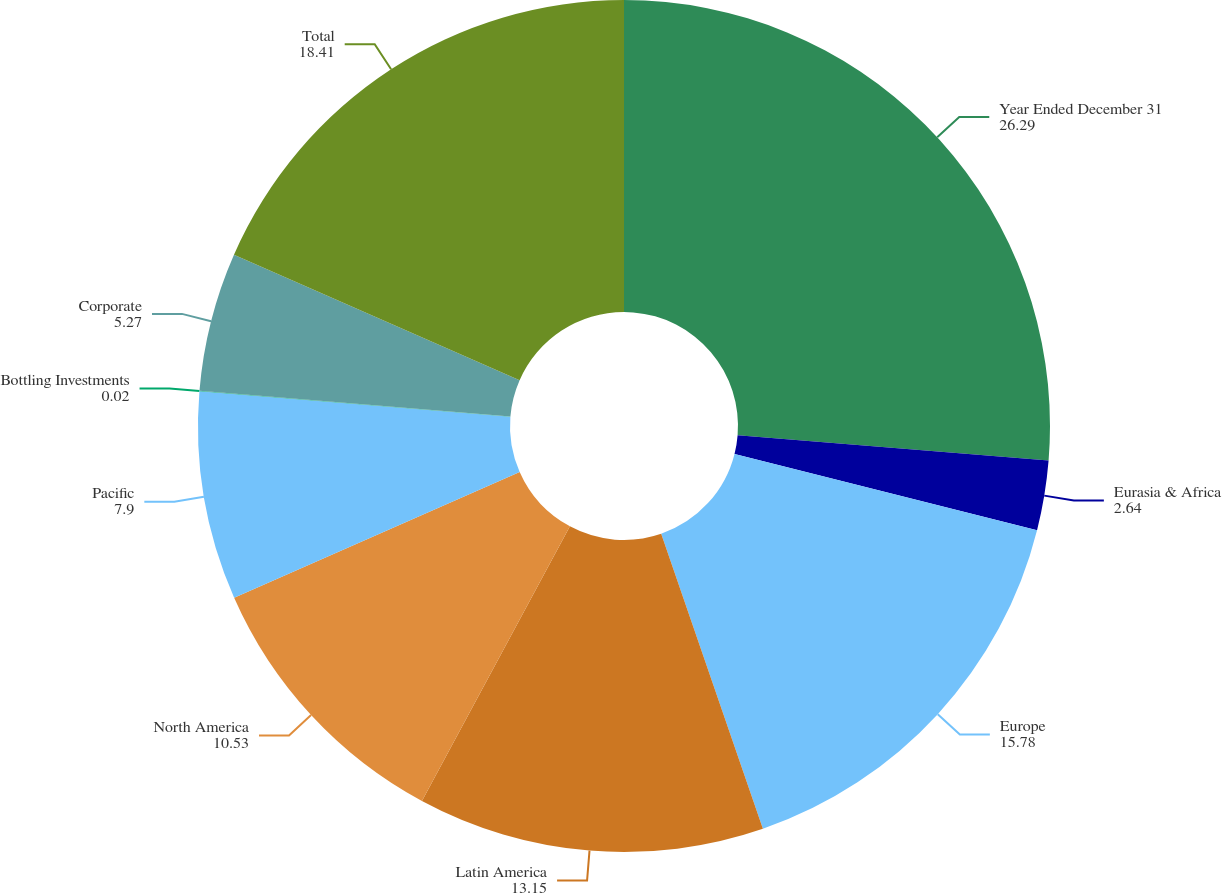Convert chart. <chart><loc_0><loc_0><loc_500><loc_500><pie_chart><fcel>Year Ended December 31<fcel>Eurasia & Africa<fcel>Europe<fcel>Latin America<fcel>North America<fcel>Pacific<fcel>Bottling Investments<fcel>Corporate<fcel>Total<nl><fcel>26.29%<fcel>2.64%<fcel>15.78%<fcel>13.15%<fcel>10.53%<fcel>7.9%<fcel>0.02%<fcel>5.27%<fcel>18.41%<nl></chart> 